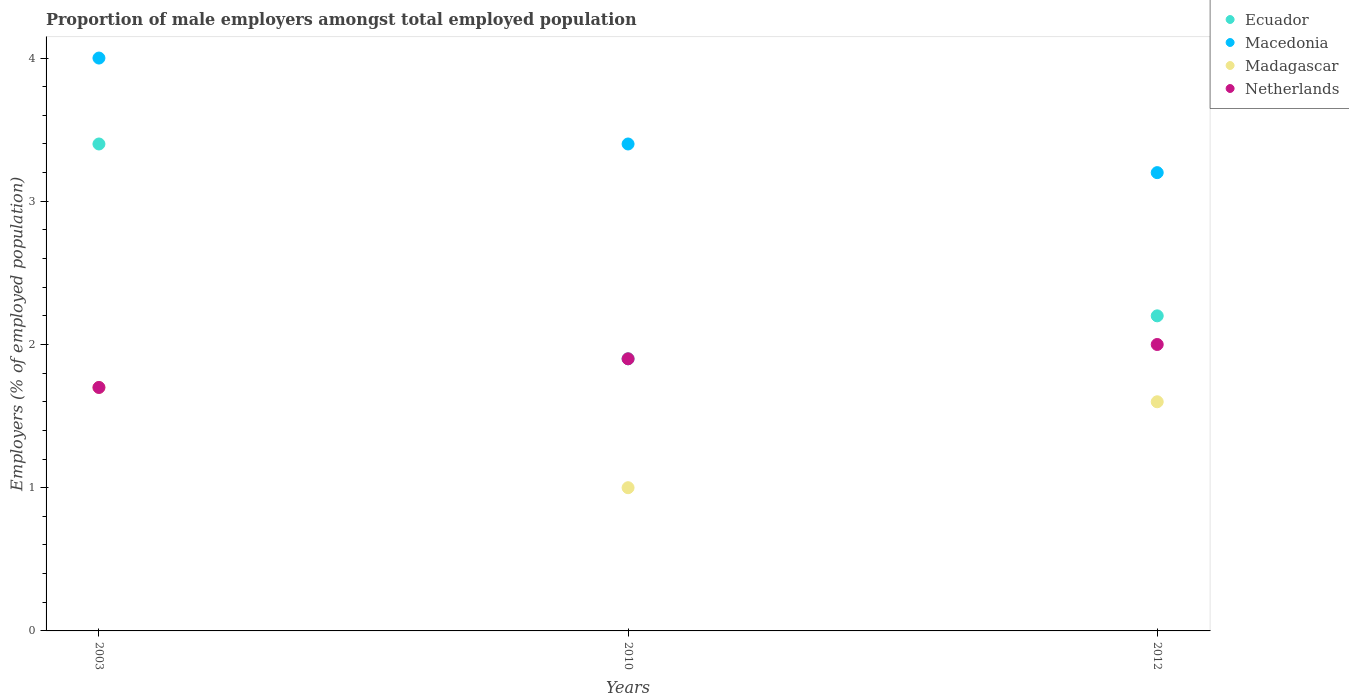How many different coloured dotlines are there?
Offer a very short reply. 4. Is the number of dotlines equal to the number of legend labels?
Keep it short and to the point. Yes. What is the proportion of male employers in Madagascar in 2003?
Give a very brief answer. 1.7. Across all years, what is the minimum proportion of male employers in Netherlands?
Offer a very short reply. 1.7. What is the total proportion of male employers in Netherlands in the graph?
Ensure brevity in your answer.  5.6. What is the difference between the proportion of male employers in Ecuador in 2010 and that in 2012?
Give a very brief answer. -0.3. What is the difference between the proportion of male employers in Madagascar in 2010 and the proportion of male employers in Macedonia in 2012?
Give a very brief answer. -2.2. What is the average proportion of male employers in Netherlands per year?
Give a very brief answer. 1.87. In the year 2010, what is the difference between the proportion of male employers in Macedonia and proportion of male employers in Netherlands?
Offer a very short reply. 1.5. What is the ratio of the proportion of male employers in Madagascar in 2010 to that in 2012?
Offer a terse response. 0.62. What is the difference between the highest and the second highest proportion of male employers in Macedonia?
Keep it short and to the point. 0.6. What is the difference between the highest and the lowest proportion of male employers in Madagascar?
Your answer should be compact. 0.7. Is the sum of the proportion of male employers in Ecuador in 2010 and 2012 greater than the maximum proportion of male employers in Macedonia across all years?
Your answer should be very brief. Yes. Does the proportion of male employers in Ecuador monotonically increase over the years?
Offer a very short reply. No. Is the proportion of male employers in Ecuador strictly greater than the proportion of male employers in Madagascar over the years?
Your response must be concise. Yes. Are the values on the major ticks of Y-axis written in scientific E-notation?
Provide a short and direct response. No. Does the graph contain grids?
Offer a terse response. No. How are the legend labels stacked?
Ensure brevity in your answer.  Vertical. What is the title of the graph?
Give a very brief answer. Proportion of male employers amongst total employed population. Does "Ghana" appear as one of the legend labels in the graph?
Ensure brevity in your answer.  No. What is the label or title of the Y-axis?
Provide a succinct answer. Employers (% of employed population). What is the Employers (% of employed population) of Ecuador in 2003?
Ensure brevity in your answer.  3.4. What is the Employers (% of employed population) of Macedonia in 2003?
Ensure brevity in your answer.  4. What is the Employers (% of employed population) of Madagascar in 2003?
Provide a succinct answer. 1.7. What is the Employers (% of employed population) in Netherlands in 2003?
Ensure brevity in your answer.  1.7. What is the Employers (% of employed population) in Ecuador in 2010?
Your answer should be very brief. 1.9. What is the Employers (% of employed population) of Macedonia in 2010?
Make the answer very short. 3.4. What is the Employers (% of employed population) of Madagascar in 2010?
Keep it short and to the point. 1. What is the Employers (% of employed population) of Netherlands in 2010?
Provide a succinct answer. 1.9. What is the Employers (% of employed population) in Ecuador in 2012?
Offer a terse response. 2.2. What is the Employers (% of employed population) of Macedonia in 2012?
Offer a terse response. 3.2. What is the Employers (% of employed population) of Madagascar in 2012?
Your answer should be compact. 1.6. What is the Employers (% of employed population) of Netherlands in 2012?
Keep it short and to the point. 2. Across all years, what is the maximum Employers (% of employed population) in Ecuador?
Keep it short and to the point. 3.4. Across all years, what is the maximum Employers (% of employed population) of Madagascar?
Offer a very short reply. 1.7. Across all years, what is the minimum Employers (% of employed population) of Ecuador?
Make the answer very short. 1.9. Across all years, what is the minimum Employers (% of employed population) in Macedonia?
Your answer should be compact. 3.2. Across all years, what is the minimum Employers (% of employed population) in Netherlands?
Provide a short and direct response. 1.7. What is the total Employers (% of employed population) of Macedonia in the graph?
Offer a very short reply. 10.6. What is the total Employers (% of employed population) of Madagascar in the graph?
Your answer should be compact. 4.3. What is the difference between the Employers (% of employed population) in Ecuador in 2003 and that in 2010?
Keep it short and to the point. 1.5. What is the difference between the Employers (% of employed population) of Macedonia in 2003 and that in 2010?
Provide a succinct answer. 0.6. What is the difference between the Employers (% of employed population) of Madagascar in 2003 and that in 2010?
Offer a very short reply. 0.7. What is the difference between the Employers (% of employed population) of Ecuador in 2003 and that in 2012?
Ensure brevity in your answer.  1.2. What is the difference between the Employers (% of employed population) of Madagascar in 2003 and that in 2012?
Your answer should be very brief. 0.1. What is the difference between the Employers (% of employed population) of Macedonia in 2010 and that in 2012?
Provide a succinct answer. 0.2. What is the difference between the Employers (% of employed population) in Ecuador in 2003 and the Employers (% of employed population) in Macedonia in 2010?
Your response must be concise. 0. What is the difference between the Employers (% of employed population) in Macedonia in 2003 and the Employers (% of employed population) in Madagascar in 2010?
Your response must be concise. 3. What is the difference between the Employers (% of employed population) in Macedonia in 2003 and the Employers (% of employed population) in Netherlands in 2010?
Provide a short and direct response. 2.1. What is the difference between the Employers (% of employed population) in Madagascar in 2003 and the Employers (% of employed population) in Netherlands in 2010?
Offer a terse response. -0.2. What is the difference between the Employers (% of employed population) of Ecuador in 2003 and the Employers (% of employed population) of Macedonia in 2012?
Provide a short and direct response. 0.2. What is the difference between the Employers (% of employed population) in Ecuador in 2003 and the Employers (% of employed population) in Madagascar in 2012?
Ensure brevity in your answer.  1.8. What is the difference between the Employers (% of employed population) of Ecuador in 2003 and the Employers (% of employed population) of Netherlands in 2012?
Ensure brevity in your answer.  1.4. What is the difference between the Employers (% of employed population) in Macedonia in 2003 and the Employers (% of employed population) in Madagascar in 2012?
Your answer should be very brief. 2.4. What is the difference between the Employers (% of employed population) of Macedonia in 2003 and the Employers (% of employed population) of Netherlands in 2012?
Your answer should be very brief. 2. What is the difference between the Employers (% of employed population) in Madagascar in 2003 and the Employers (% of employed population) in Netherlands in 2012?
Offer a very short reply. -0.3. What is the difference between the Employers (% of employed population) in Ecuador in 2010 and the Employers (% of employed population) in Macedonia in 2012?
Ensure brevity in your answer.  -1.3. What is the difference between the Employers (% of employed population) in Ecuador in 2010 and the Employers (% of employed population) in Madagascar in 2012?
Make the answer very short. 0.3. What is the difference between the Employers (% of employed population) in Ecuador in 2010 and the Employers (% of employed population) in Netherlands in 2012?
Keep it short and to the point. -0.1. What is the difference between the Employers (% of employed population) of Macedonia in 2010 and the Employers (% of employed population) of Madagascar in 2012?
Make the answer very short. 1.8. What is the difference between the Employers (% of employed population) in Macedonia in 2010 and the Employers (% of employed population) in Netherlands in 2012?
Your answer should be compact. 1.4. What is the difference between the Employers (% of employed population) in Madagascar in 2010 and the Employers (% of employed population) in Netherlands in 2012?
Provide a succinct answer. -1. What is the average Employers (% of employed population) of Ecuador per year?
Give a very brief answer. 2.5. What is the average Employers (% of employed population) of Macedonia per year?
Ensure brevity in your answer.  3.53. What is the average Employers (% of employed population) of Madagascar per year?
Provide a succinct answer. 1.43. What is the average Employers (% of employed population) of Netherlands per year?
Your answer should be compact. 1.87. In the year 2003, what is the difference between the Employers (% of employed population) in Ecuador and Employers (% of employed population) in Macedonia?
Offer a very short reply. -0.6. In the year 2003, what is the difference between the Employers (% of employed population) of Ecuador and Employers (% of employed population) of Madagascar?
Provide a succinct answer. 1.7. In the year 2003, what is the difference between the Employers (% of employed population) in Macedonia and Employers (% of employed population) in Madagascar?
Ensure brevity in your answer.  2.3. In the year 2003, what is the difference between the Employers (% of employed population) of Macedonia and Employers (% of employed population) of Netherlands?
Your answer should be very brief. 2.3. In the year 2003, what is the difference between the Employers (% of employed population) in Madagascar and Employers (% of employed population) in Netherlands?
Keep it short and to the point. 0. In the year 2010, what is the difference between the Employers (% of employed population) of Macedonia and Employers (% of employed population) of Netherlands?
Offer a terse response. 1.5. In the year 2012, what is the difference between the Employers (% of employed population) of Ecuador and Employers (% of employed population) of Macedonia?
Your response must be concise. -1. In the year 2012, what is the difference between the Employers (% of employed population) of Macedonia and Employers (% of employed population) of Madagascar?
Your answer should be very brief. 1.6. What is the ratio of the Employers (% of employed population) of Ecuador in 2003 to that in 2010?
Keep it short and to the point. 1.79. What is the ratio of the Employers (% of employed population) of Macedonia in 2003 to that in 2010?
Your answer should be compact. 1.18. What is the ratio of the Employers (% of employed population) of Netherlands in 2003 to that in 2010?
Ensure brevity in your answer.  0.89. What is the ratio of the Employers (% of employed population) of Ecuador in 2003 to that in 2012?
Your response must be concise. 1.55. What is the ratio of the Employers (% of employed population) in Macedonia in 2003 to that in 2012?
Offer a very short reply. 1.25. What is the ratio of the Employers (% of employed population) of Ecuador in 2010 to that in 2012?
Ensure brevity in your answer.  0.86. What is the ratio of the Employers (% of employed population) in Netherlands in 2010 to that in 2012?
Keep it short and to the point. 0.95. What is the difference between the highest and the second highest Employers (% of employed population) in Netherlands?
Give a very brief answer. 0.1. What is the difference between the highest and the lowest Employers (% of employed population) in Macedonia?
Keep it short and to the point. 0.8. 